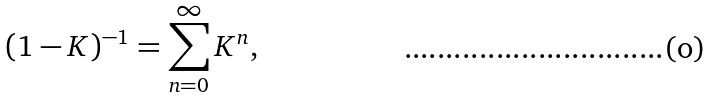<formula> <loc_0><loc_0><loc_500><loc_500>( 1 - K ) ^ { - 1 } = \sum ^ { \infty } _ { n = 0 } K ^ { n } ,</formula> 